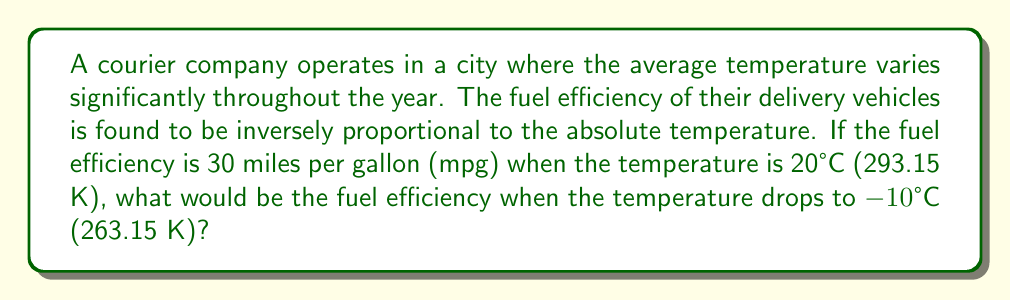Can you solve this math problem? Let's approach this step-by-step:

1) First, we need to understand the relationship between fuel efficiency (E) and absolute temperature (T). It's given that they are inversely proportional:

   $E \propto \frac{1}{T}$

2) This relationship can be written as an equation:

   $E = \frac{k}{T}$

   where k is a constant.

3) We can find the value of k using the given information:
   At 20°C (293.15 K), E = 30 mpg

   $30 = \frac{k}{293.15}$

4) Solving for k:

   $k = 30 \times 293.15 = 8794.5$

5) Now that we know k, we can use it to find E at -10°C (263.15 K):

   $E = \frac{8794.5}{263.15}$

6) Calculating this:

   $E = 33.42$ mpg

Therefore, when the temperature drops to -10°C, the fuel efficiency would increase to approximately 33.42 mpg.
Answer: 33.42 mpg 